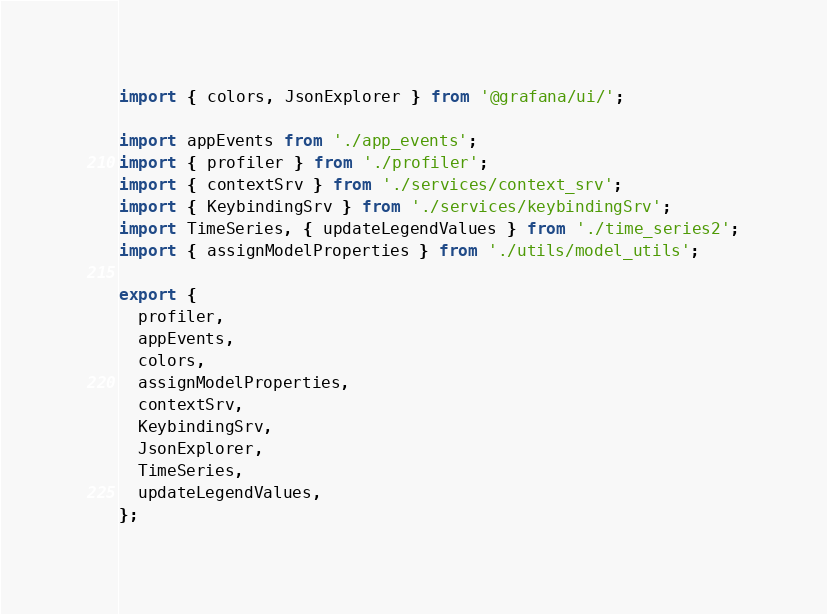Convert code to text. <code><loc_0><loc_0><loc_500><loc_500><_TypeScript_>import { colors, JsonExplorer } from '@grafana/ui/';

import appEvents from './app_events';
import { profiler } from './profiler';
import { contextSrv } from './services/context_srv';
import { KeybindingSrv } from './services/keybindingSrv';
import TimeSeries, { updateLegendValues } from './time_series2';
import { assignModelProperties } from './utils/model_utils';

export {
  profiler,
  appEvents,
  colors,
  assignModelProperties,
  contextSrv,
  KeybindingSrv,
  JsonExplorer,
  TimeSeries,
  updateLegendValues,
};
</code> 